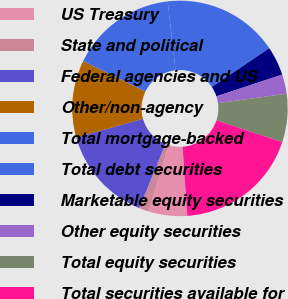Convert chart to OTSL. <chart><loc_0><loc_0><loc_500><loc_500><pie_chart><fcel>US Treasury<fcel>State and political<fcel>Federal agencies and US<fcel>Other/non-agency<fcel>Total mortgage-backed<fcel>Total debt securities<fcel>Marketable equity securities<fcel>Other equity securities<fcel>Total equity securities<fcel>Total securities available for<nl><fcel>5.8%<fcel>1.45%<fcel>14.49%<fcel>11.59%<fcel>15.94%<fcel>17.39%<fcel>4.35%<fcel>2.9%<fcel>7.25%<fcel>18.84%<nl></chart> 